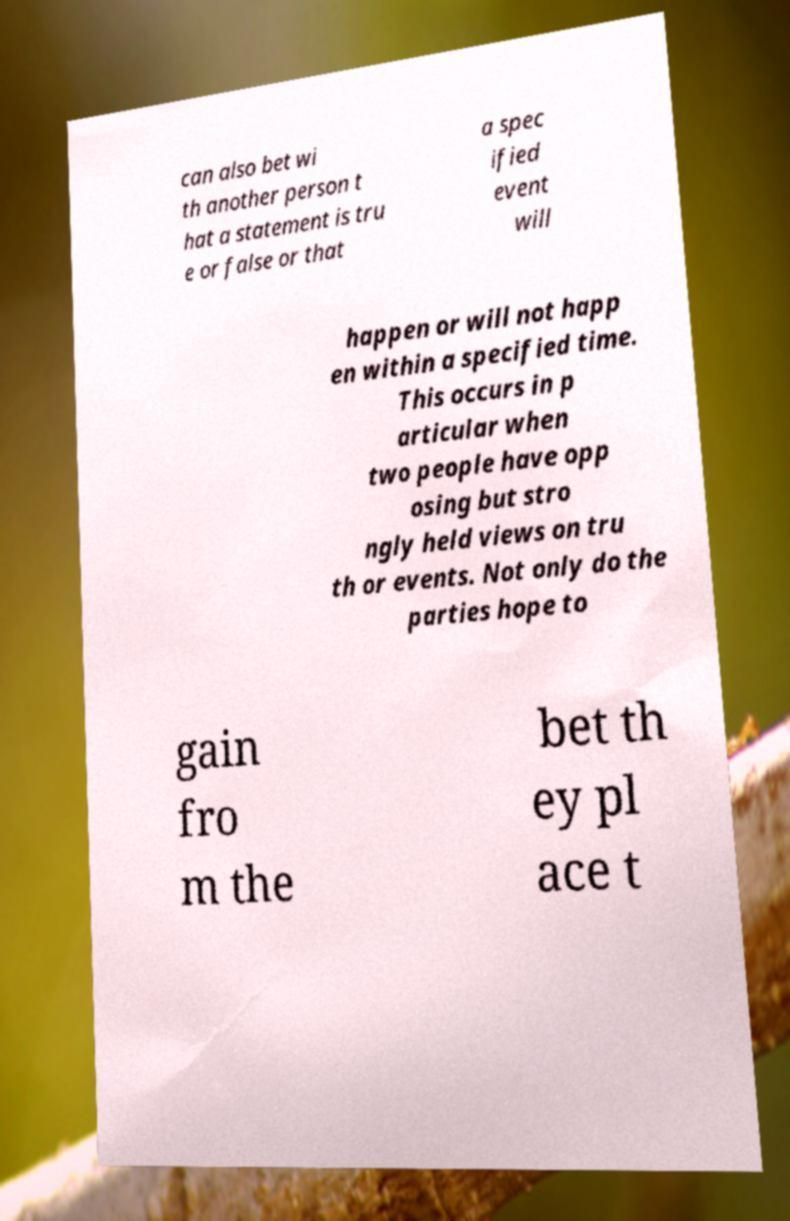I need the written content from this picture converted into text. Can you do that? can also bet wi th another person t hat a statement is tru e or false or that a spec ified event will happen or will not happ en within a specified time. This occurs in p articular when two people have opp osing but stro ngly held views on tru th or events. Not only do the parties hope to gain fro m the bet th ey pl ace t 